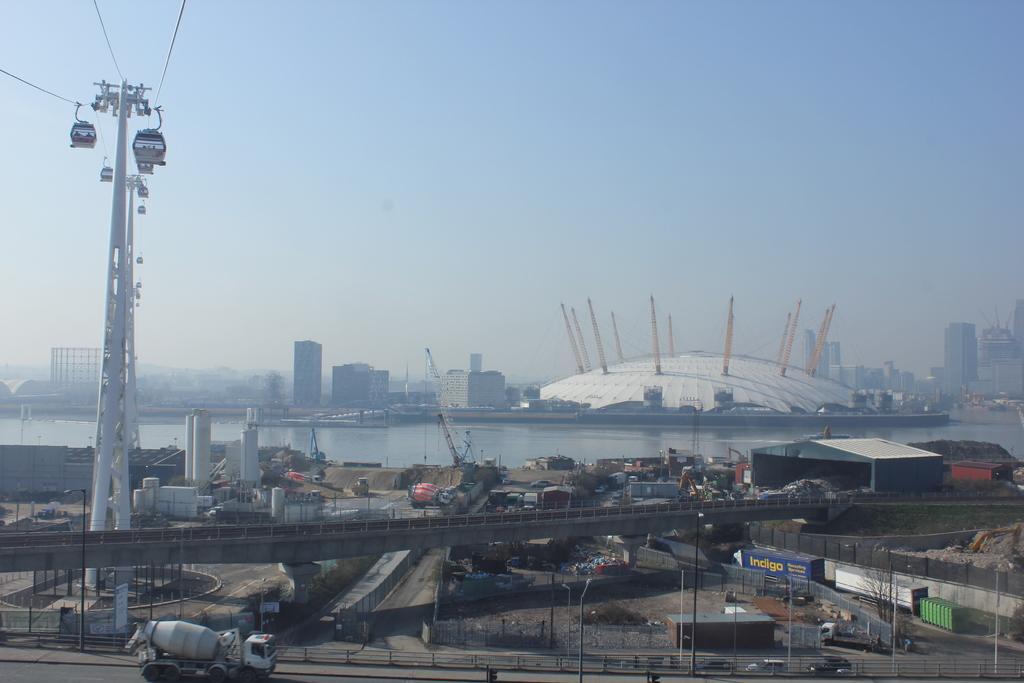Describe this image in one or two sentences. In this image we can see poles, vehicles, cable cars, bridge, containers, pillars, shed, towers, water, and buildings. In the background there is sky. 